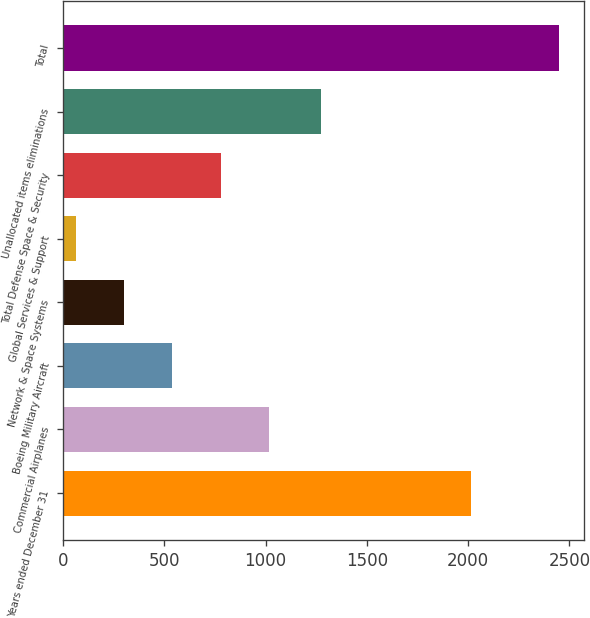Convert chart to OTSL. <chart><loc_0><loc_0><loc_500><loc_500><bar_chart><fcel>Years ended December 31<fcel>Commercial Airplanes<fcel>Boeing Military Aircraft<fcel>Network & Space Systems<fcel>Global Services & Support<fcel>Total Defense Space & Security<fcel>Unallocated items eliminations<fcel>Total<nl><fcel>2015<fcel>1017.2<fcel>539.6<fcel>300.8<fcel>62<fcel>778.4<fcel>1273<fcel>2450<nl></chart> 